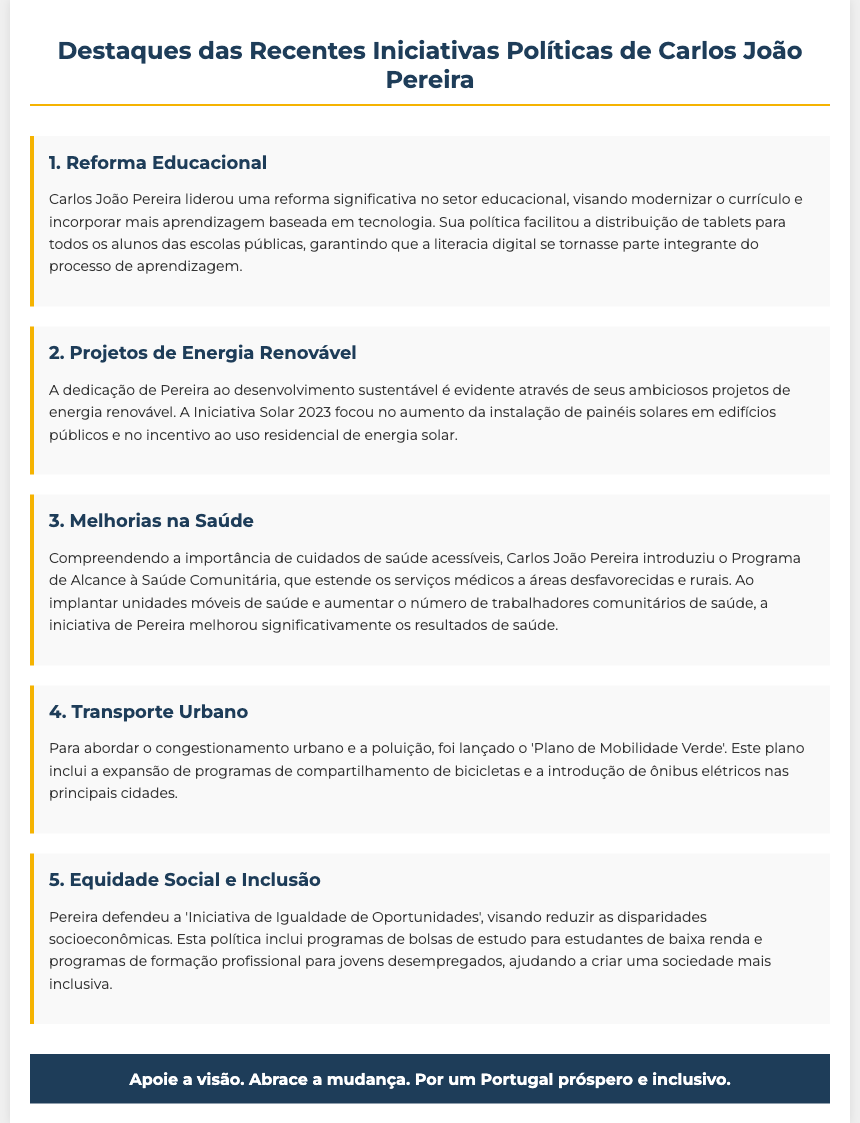What is the focus of the educational reform? The educational reform aims to modernize the curriculum and incorporate more technology-based learning.
Answer: Modernize the curriculum What initiative is related to renewable energy? The initiative mentioned for renewable energy is the Iniciativa Solar 2023, which focuses on the installation of solar panels.
Answer: Iniciativa Solar 2023 What program did Carlos João Pereira introduce for healthcare access? The program introduced is the Programa de Alcance à Saúde Comunitária, aimed at extending medical services to underserved areas.
Answer: Programa de Alcance à Saúde Comunitária What is the goal of the 'Plano de Mobilidade Verde'? The goal of the 'Plano de Mobilidade Verde' is to address urban congestion and pollution.
Answer: Address urban congestion What type of social initiative is mentioned in the document? The document refers to the 'Iniciativa de Igualdade de Oportunidades', which aims to reduce socioeconomic disparities.
Answer: Iniciativa de Igualdade de Oportunidades How many key projects are highlighted in the flyer? The document highlights five key projects related to Carlos João Pereira's initiatives.
Answer: Five What is the primary target of the health initiative? The primary target of the health initiative is to extend services to disadvantaged and rural communities.
Answer: Disadvantaged and rural communities What support does the document suggest for low-income students? The document suggests programs of scholarships for low-income students to support their education.
Answer: Scholarships What environmental measure is included in the transportation initiative? The transportation initiative includes the introduction of electric buses in major cities.
Answer: Electric buses 